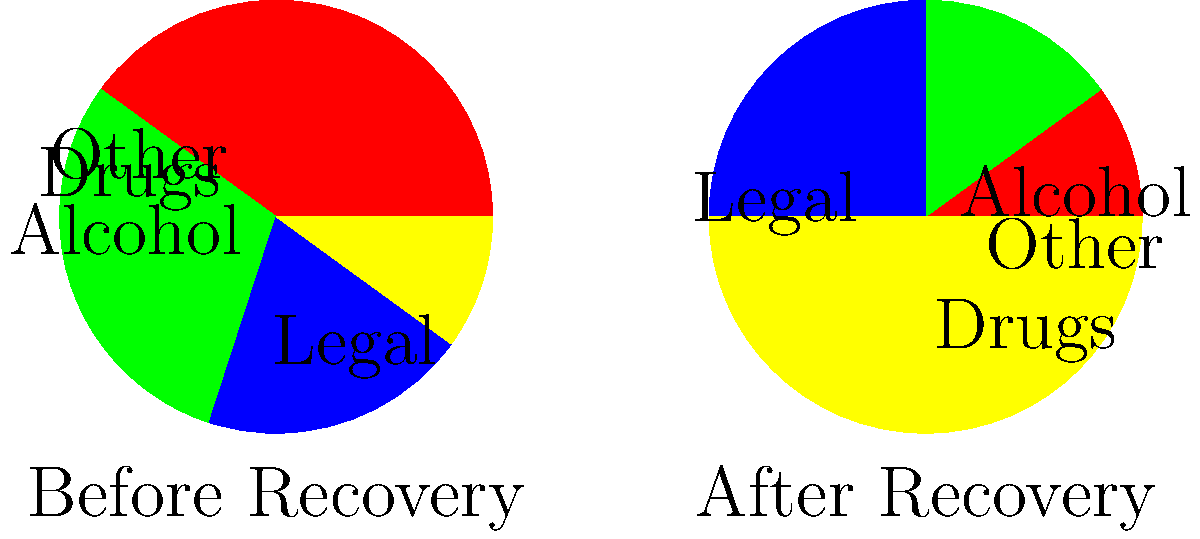The pie charts above show the expense categories for a recovering addict before and after joining a recovery program. If their total monthly expenses were $2000 before recovery and $1500 after recovery, what is the difference in dollars spent on drugs and alcohol combined? To solve this problem, we need to follow these steps:

1. Calculate the percentage of expenses for drugs and alcohol before recovery:
   Drugs: 40%, Alcohol: 30%
   Combined: 40% + 30% = 70%

2. Calculate the amount spent on drugs and alcohol before recovery:
   70% of $2000 = $2000 * 0.70 = $1400

3. Calculate the percentage of expenses for drugs and alcohol after recovery:
   Drugs: 10%, Alcohol: 15%
   Combined: 10% + 15% = 25%

4. Calculate the amount spent on drugs and alcohol after recovery:
   25% of $1500 = $1500 * 0.25 = $375

5. Calculate the difference in spending:
   $1400 - $375 = $1025

Therefore, the difference in dollars spent on drugs and alcohol combined is $1025.
Answer: $1025 